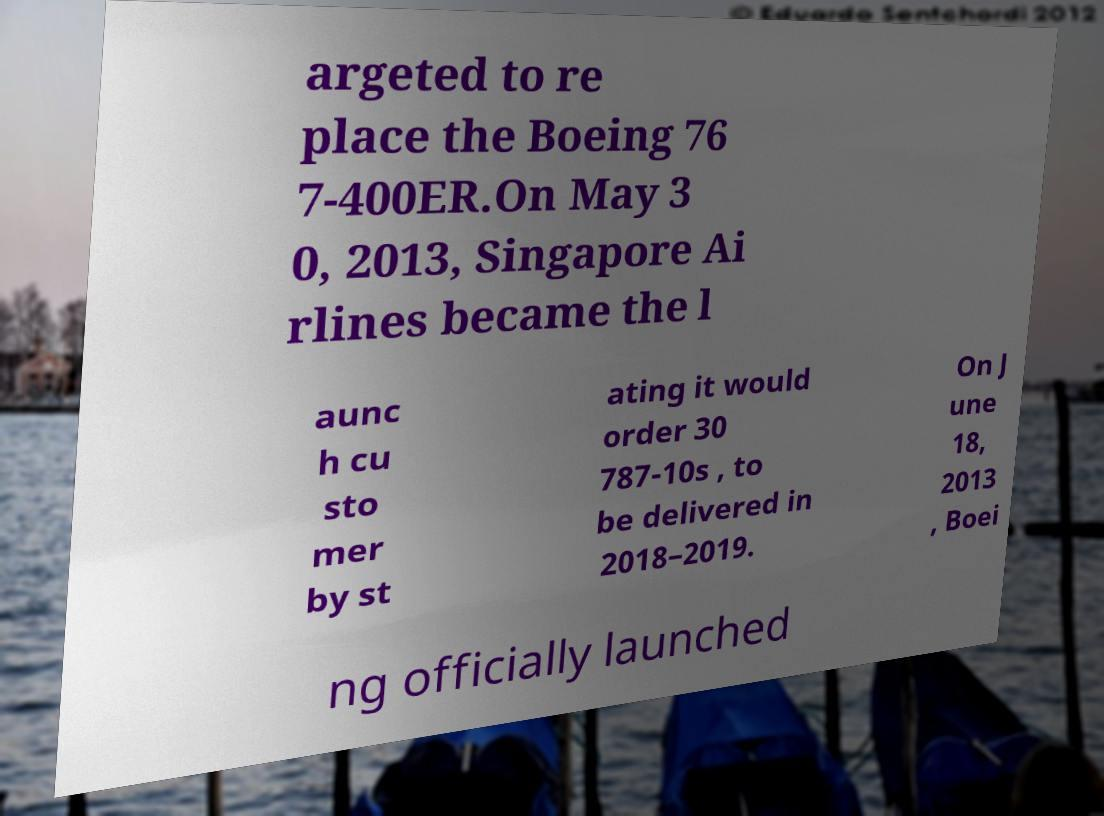For documentation purposes, I need the text within this image transcribed. Could you provide that? argeted to re place the Boeing 76 7-400ER.On May 3 0, 2013, Singapore Ai rlines became the l aunc h cu sto mer by st ating it would order 30 787-10s , to be delivered in 2018–2019. On J une 18, 2013 , Boei ng officially launched 